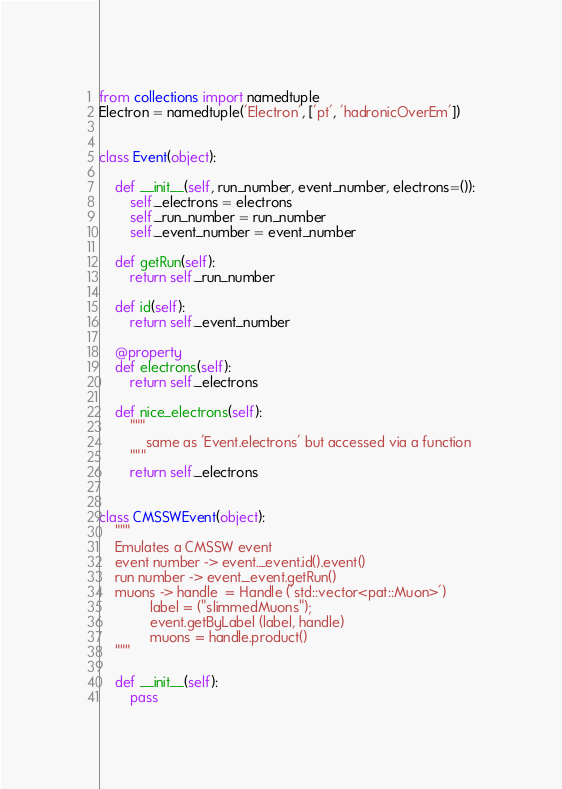Convert code to text. <code><loc_0><loc_0><loc_500><loc_500><_Python_>from collections import namedtuple
Electron = namedtuple('Electron', ['pt', 'hadronicOverEm'])


class Event(object):

    def __init__(self, run_number, event_number, electrons=()):
        self._electrons = electrons
        self._run_number = run_number
        self._event_number = event_number

    def getRun(self):
        return self._run_number

    def id(self):
        return self._event_number

    @property
    def electrons(self):
        return self._electrons

    def nice_electrons(self):
        """
            same as 'Event.electrons' but accessed via a function
        """
        return self._electrons


class CMSSWEvent(object):
    """
    Emulates a CMSSW event
    event number -> event._event.id().event()
    run number -> event._event.getRun()
    muons -> handle  = Handle ('std::vector<pat::Muon>')
             label = ("slimmedMuons");
             event.getByLabel (label, handle)
             muons = handle.product()
    """

    def __init__(self):
        pass
</code> 